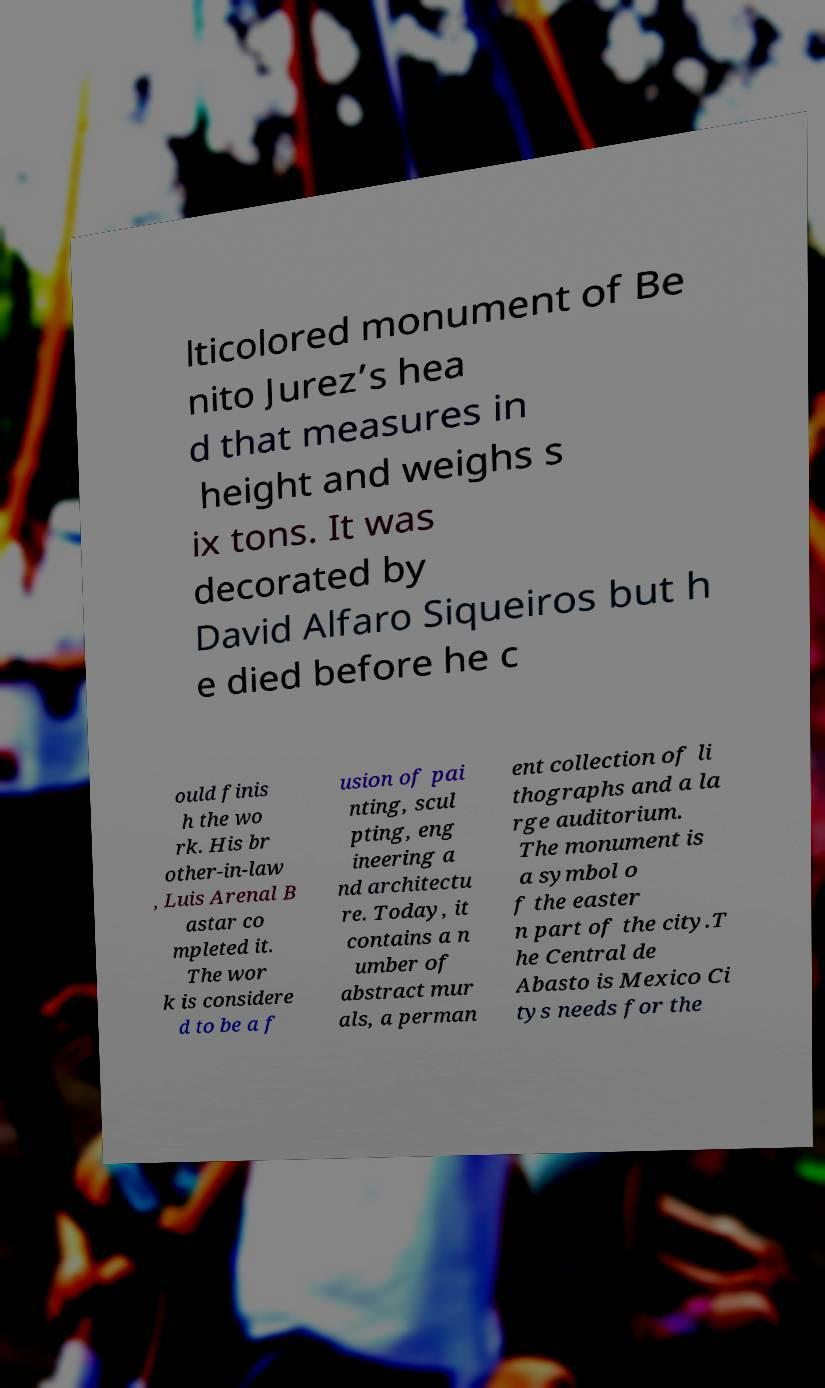Can you read and provide the text displayed in the image?This photo seems to have some interesting text. Can you extract and type it out for me? lticolored monument of Be nito Jurez’s hea d that measures in height and weighs s ix tons. It was decorated by David Alfaro Siqueiros but h e died before he c ould finis h the wo rk. His br other-in-law , Luis Arenal B astar co mpleted it. The wor k is considere d to be a f usion of pai nting, scul pting, eng ineering a nd architectu re. Today, it contains a n umber of abstract mur als, a perman ent collection of li thographs and a la rge auditorium. The monument is a symbol o f the easter n part of the city.T he Central de Abasto is Mexico Ci tys needs for the 